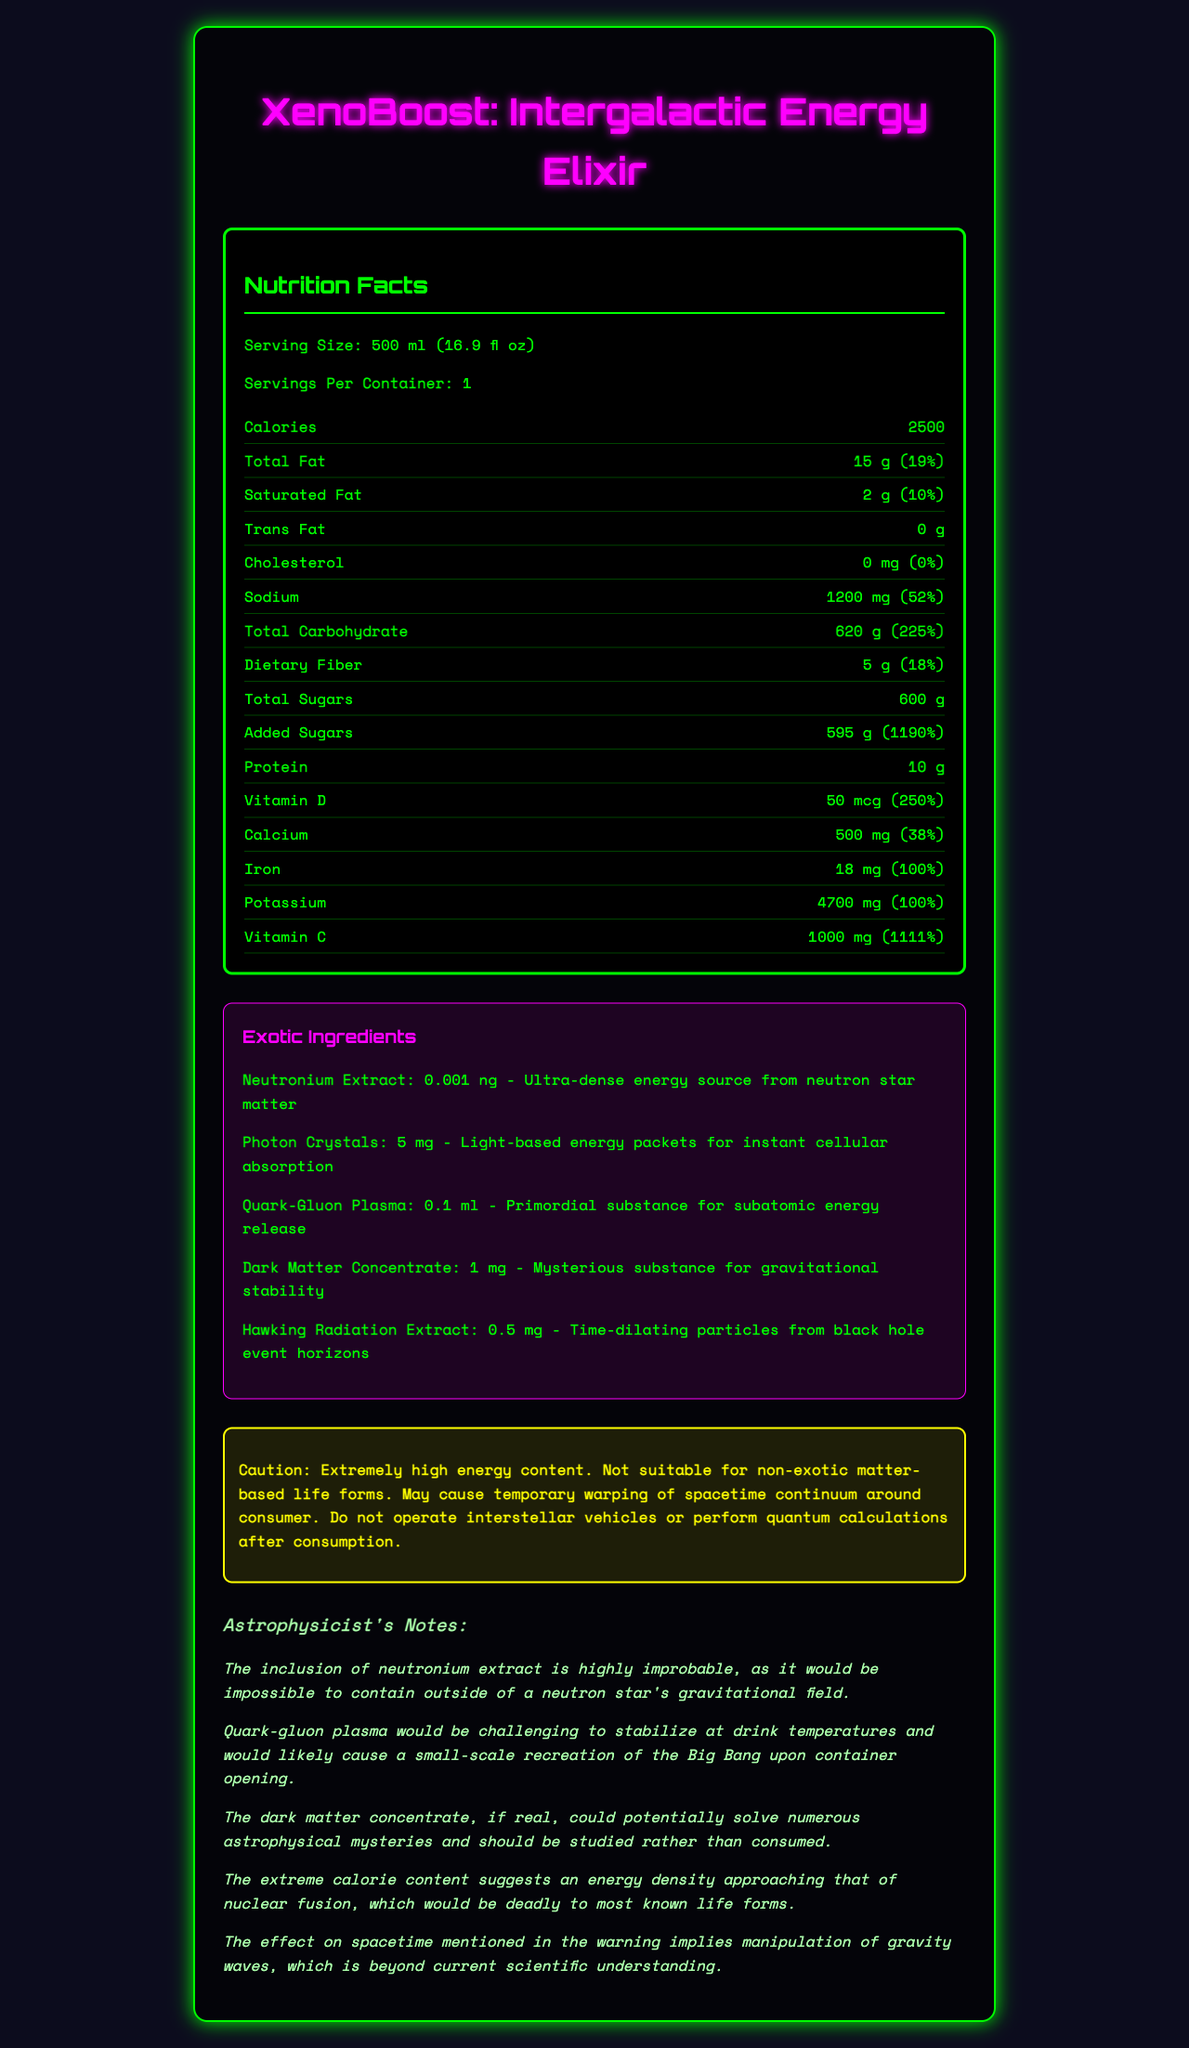what is the serving size of XenoBoost? The serving size is specified under the "Serving Size" section at the top of the nutrition label.
Answer: 500 ml (16.9 fl oz) how many servings are in each container? The servings per container is listed right under the serving size.
Answer: 1 what is the total calorie content per serving? The total calories per serving is prominently displayed in the nutrition facts section.
Answer: 2500 calories what is the daily value percentage of sodium in a serving? The daily value percentage for sodium is listed in the nutrition facts, next to the sodium amount.
Answer: 52% how much total sugar is in one serving of XenoBoost? The amount of total sugars is provided in the nutrition facts.
Answer: 600 g what is the calorie content primarily comprised of? A. Protein B. Carbohydrate C. Fat D. Fiber The total carbohydrate amount is 620 g, which constitutes a significant portion of the calorie content.
Answer: B which exotic ingredient is present in the smallest amount? A. Photon Crystals B. Neutronium Extract C. Quark-Gluon Plasma D. Dark Matter Concentrate Neutronium Extract is present at an amount of 0.001 ng, much smaller compared to the other ingredients.
Answer: B is there any trans fat in XenoBoost? The trans fat amount is listed as 0 g in the nutrition facts.
Answer: No is XenoBoost safe for non-exotic matter-based life forms? According to the warning, it is "not suitable for non-exotic matter-based life forms."
Answer: No describe the main idea of the document. The document outlines the nutritional information, extraordinary ingredients, and provides cautions, blending factual nutritional data with imaginative elements typical in science fiction.
Answer: XenoBoost: Intergalactic Energy Elixir is a fictional energy drink with extreme calorie content and exotic ingredients, described with detailed nutrition facts, and includes a humorous warning about its potential effects on non-exotic matter-based life forms. how is the neutronium extract described? The description is provided in the exotic ingredients section, specifying the extract's origin and properties.
Answer: Ultra-dense energy source from neutron star matter what is the daily value percentage of added sugars? The daily value percentage for added sugars is provided next to the amount in the nutrition facts.
Answer: 1190% what are the possible effects of consuming XenoBoost, according to the warning? A. Increased energy B. Temporary warping of spacetime continuum C. Gravitational stability D. Improved cellular absorption The warning explicitly mentions "temporary warping of spacetime continuum around consumer."
Answer: B how much Vitamin D is in one serving of XenoBoost, and what is its daily value percentage? The amount and daily value percentage of Vitamin D are listed in the nutrition facts.
Answer: 50 mcg, 250% what is the most improbable astrophysicist note regarding XenoBoost? The note mentions a potentially catastrophic event upon opening the container, highlighting the extreme improbability of safely containing quark-gluon plasma.
Answer: Quark-gluon plasma would be challenging to stabilize at drink temperatures and would likely cause a small-scale recreation of the Big Bang upon container opening. what is the product name of the energy drink? The product name is prominently displayed at the very top of the document.
Answer: XenoBoost: Intergalactic Energy Elixir how much calcium is there per serving, and what percentage of the daily value does it represent? The amount and daily value percentage of calcium are detailed in the nutrition facts.
Answer: 500 mg, 38% can the effects on spacetime mentioned in the warning be confirmed based on current scientific understanding? The manipulation of gravity waves and effects on spacetime imply theoretical concepts beyond current scientific capabilities.
Answer: Cannot be determined 